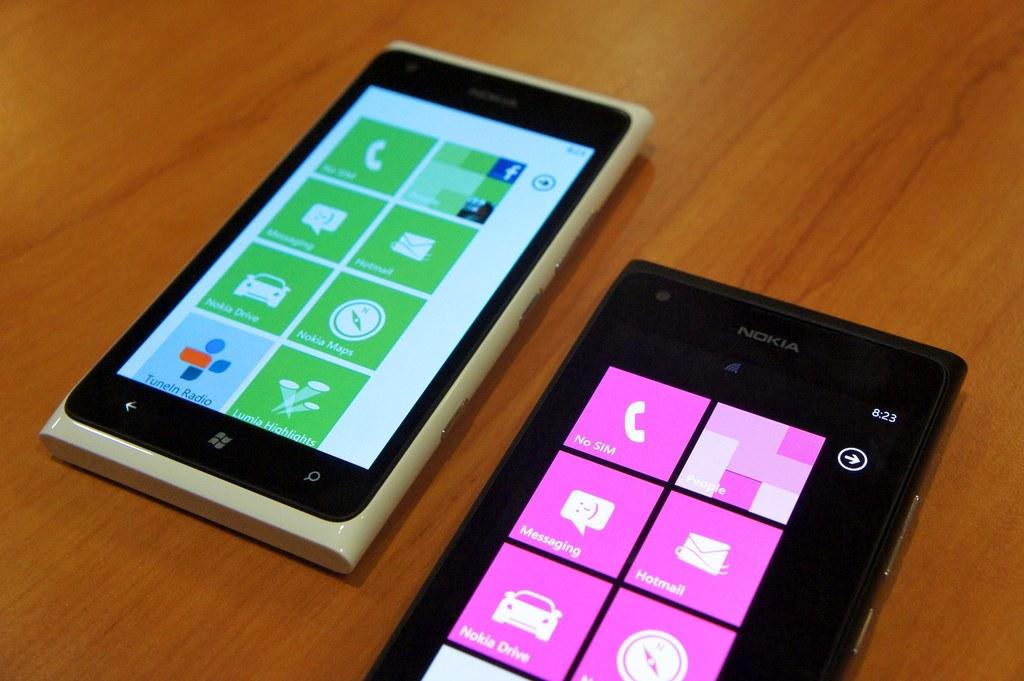What electronic devices can be seen in the image? There are two cell phones in the image. Where are the cell phones located in the image? The cell phones are in the center of the image. On what surface are the cell phones placed? The cell phones are on a table. What type of plane can be seen flying over the cell phones in the image? There is no plane visible in the image; it only features two cell phones on a table. What kind of horn is being used by the giants in the image? There are no giants or horns present in the image. 